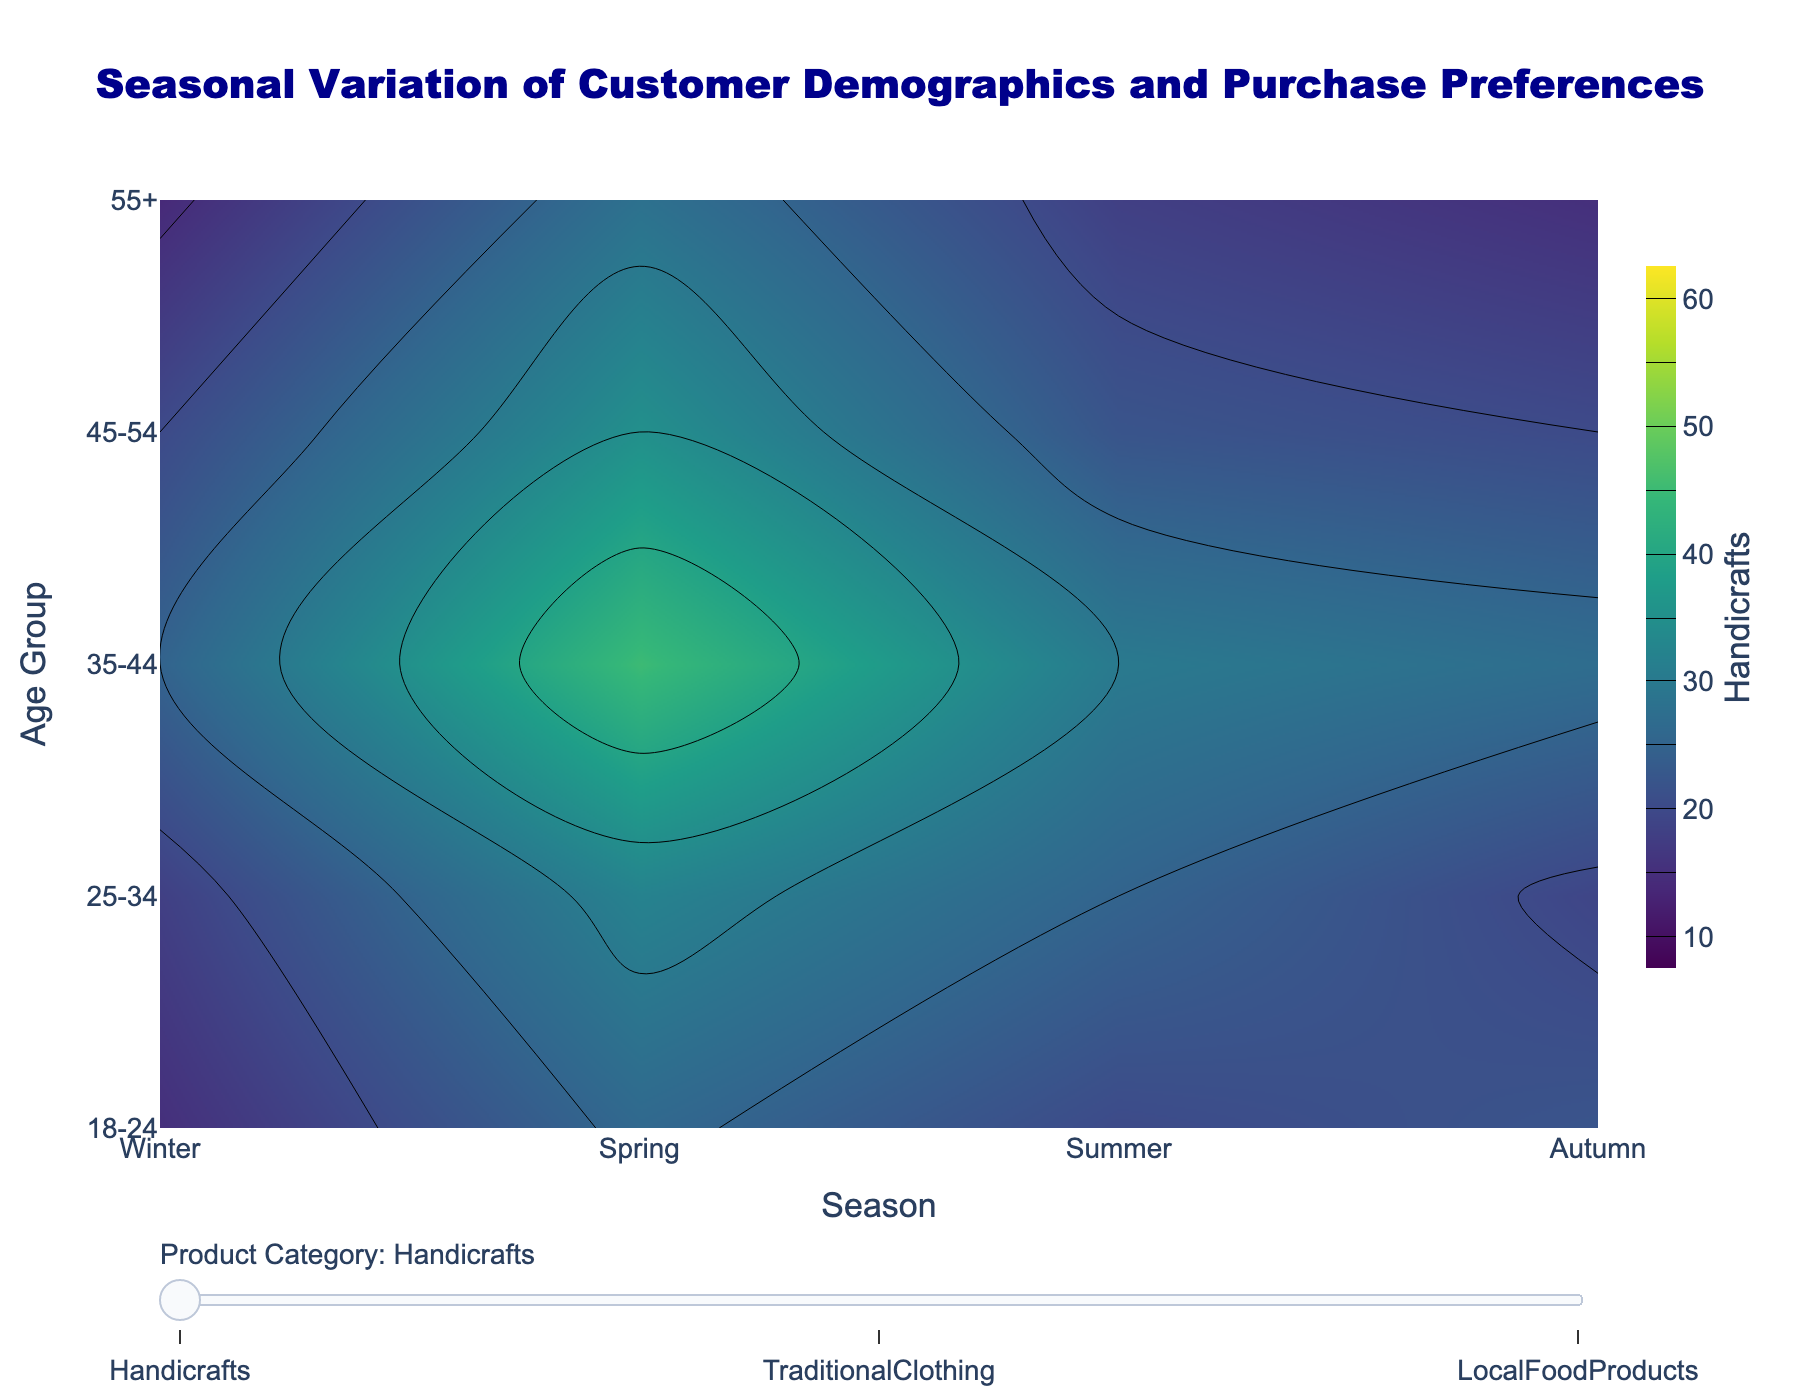What's the title of the figure? The title of the figure is usually placed at the top and in this case, it reads "Seasonal Variation of Customer Demographics and Purchase Preferences".
Answer: Seasonal Variation of Customer Demographics and Purchase Preferences Which season shows the highest preference for Local Food Products among the 35-44 age group? Observing the contour plot for Local Food Products, the highest contour levels for the 35-44 age group occur in the Spring season.
Answer: Spring How does the winter preference for Traditional Clothing in the 55+ age group compare to the spring preference in the same age group? In the contour plot for Traditional Clothing, locate the 55+ age group and compare the values for Winter and Spring. The value for Winter is lower than that for Spring.
Answer: Spring is higher Among the different seasons, which one has the lowest preference for Handicrafts in the 18-24 age group? Observing the contour plot for Handicrafts, the lowest contour levels for the 18-24 age group are seen in the Autumn season.
Answer: Autumn What is the overall preference trend for Local Food Products across all age groups from Winter to Spring? Comparing the contour levels of Local Food Products from Winter to Spring, we observe that the contour levels generally increase from Winter to Spring across all age groups, indicating higher preferences.
Answer: Increasing Which product category demonstrates the most significant preference change for the 25-34 age group across the seasons? By comparing the contour plots for Handicrafts, Traditional Clothing, and Local Food Products, it's evident that Local Food Products show the most significant change, with preference levels varying greatly.
Answer: Local Food Products What is the age group with the highest preference for Traditional Clothing in Summer? From the contour plot for Traditional Clothing, the highest contour levels during Summer are present in the 35-44 age group.
Answer: 35-44 Compare the preference for Handicrafts and Traditional Clothing for the 45-54 age group in Autumn. Observing the contour plots for Handicrafts and Traditional Clothing, the values for both products are seen. For the 45-54 age group in Autumn, the preference for Handicrafts appears slightly higher than for Traditional Clothing.
Answer: Handicrafts is higher During which season does the 55+ age group have the lowest preference for Local Food Products? By looking at the contour plot for Local Food Products, the lowest contour levels for the 55+ age group are observed in the Autumn season.
Answer: Autumn How does the preference for Handicrafts differ between Spring and Summer for the 25-34 age group? Observing the contour plot for Handicrafts, the contour levels for the 25-34 age group are higher in Spring compared to Summer, indicating higher preferences in Spring.
Answer: Higher in Spring 